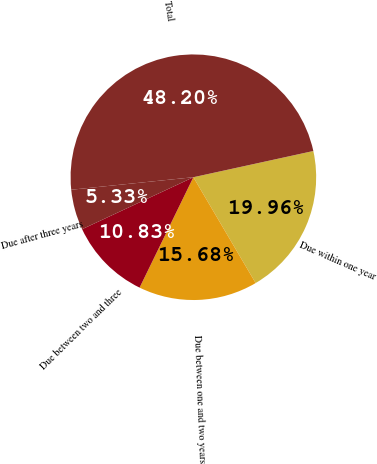<chart> <loc_0><loc_0><loc_500><loc_500><pie_chart><fcel>Due within one year<fcel>Due between one and two years<fcel>Due between two and three<fcel>Due after three years<fcel>Total<nl><fcel>19.96%<fcel>15.68%<fcel>10.83%<fcel>5.33%<fcel>48.2%<nl></chart> 